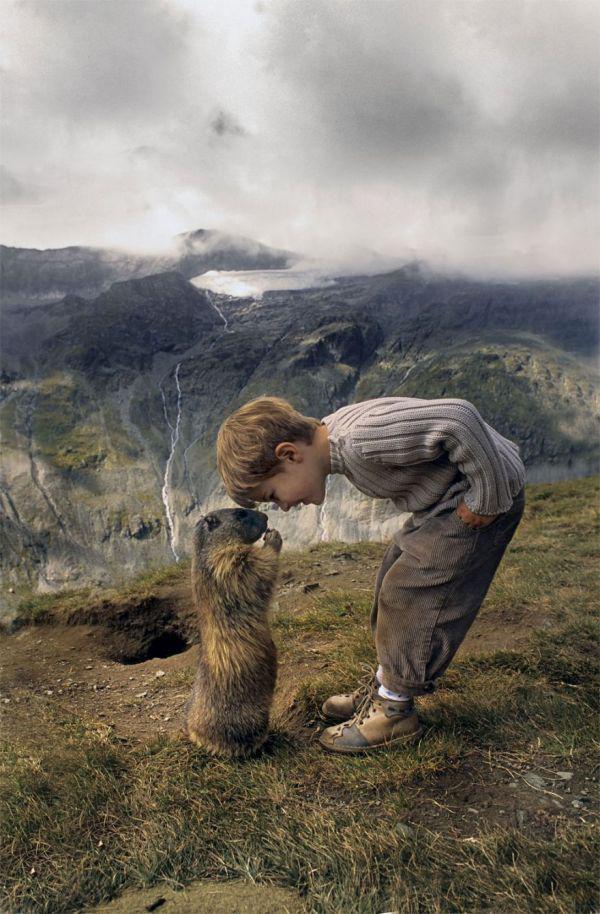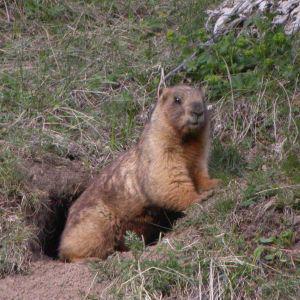The first image is the image on the left, the second image is the image on the right. Examine the images to the left and right. Is the description "A young boy is next to at least one groundhog." accurate? Answer yes or no. Yes. The first image is the image on the left, the second image is the image on the right. Examine the images to the left and right. Is the description "In one image there is a boy next to at least one marmot." accurate? Answer yes or no. Yes. 